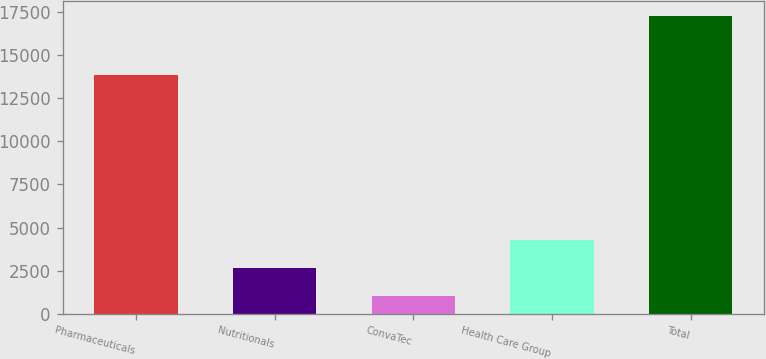Convert chart to OTSL. <chart><loc_0><loc_0><loc_500><loc_500><bar_chart><fcel>Pharmaceuticals<fcel>Nutritionals<fcel>ConvaTec<fcel>Health Care Group<fcel>Total<nl><fcel>13861<fcel>2668.8<fcel>1048<fcel>4289.6<fcel>17256<nl></chart> 